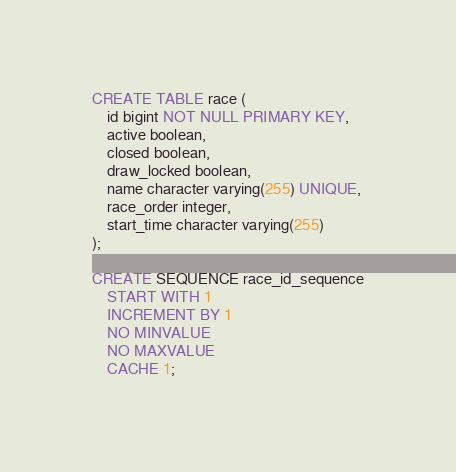Convert code to text. <code><loc_0><loc_0><loc_500><loc_500><_SQL_>CREATE TABLE race (
    id bigint NOT NULL PRIMARY KEY,
    active boolean,
    closed boolean,
    draw_locked boolean,
    name character varying(255) UNIQUE,
    race_order integer,
    start_time character varying(255)
);

CREATE SEQUENCE race_id_sequence
    START WITH 1
    INCREMENT BY 1
    NO MINVALUE
    NO MAXVALUE
    CACHE 1;</code> 